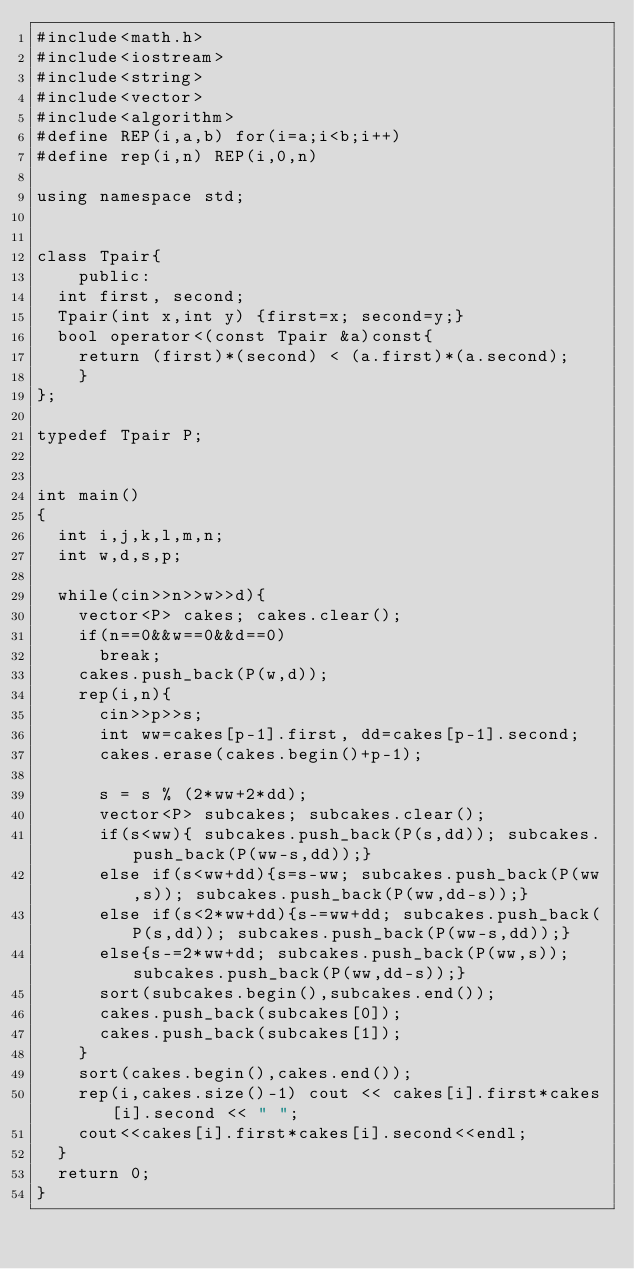Convert code to text. <code><loc_0><loc_0><loc_500><loc_500><_C++_>#include<math.h>
#include<iostream>
#include<string>
#include<vector>
#include<algorithm>
#define REP(i,a,b) for(i=a;i<b;i++)
#define rep(i,n) REP(i,0,n)

using namespace std;


class Tpair{
    public: 
	int first, second;
	Tpair(int x,int y) {first=x; second=y;}
	bool operator<(const Tpair &a)const{
		return (first)*(second) < (a.first)*(a.second);
    }
};

typedef Tpair P;


int main()
{
	int i,j,k,l,m,n;
	int w,d,s,p;
	
	while(cin>>n>>w>>d){
		vector<P> cakes; cakes.clear();
		if(n==0&&w==0&&d==0)
			break;
		cakes.push_back(P(w,d));
		rep(i,n){
			cin>>p>>s;
			int ww=cakes[p-1].first, dd=cakes[p-1].second;
			cakes.erase(cakes.begin()+p-1);

			s = s % (2*ww+2*dd);
			vector<P> subcakes; subcakes.clear();
			if(s<ww){ subcakes.push_back(P(s,dd)); subcakes.push_back(P(ww-s,dd));}
			else if(s<ww+dd){s=s-ww; subcakes.push_back(P(ww,s)); subcakes.push_back(P(ww,dd-s));}
			else if(s<2*ww+dd){s-=ww+dd; subcakes.push_back(P(s,dd)); subcakes.push_back(P(ww-s,dd));}
			else{s-=2*ww+dd; subcakes.push_back(P(ww,s)); subcakes.push_back(P(ww,dd-s));}
			sort(subcakes.begin(),subcakes.end());
			cakes.push_back(subcakes[0]);
			cakes.push_back(subcakes[1]);
		}
		sort(cakes.begin(),cakes.end());
		rep(i,cakes.size()-1) cout << cakes[i].first*cakes[i].second << " ";
		cout<<cakes[i].first*cakes[i].second<<endl;
	}
	return 0;
}</code> 